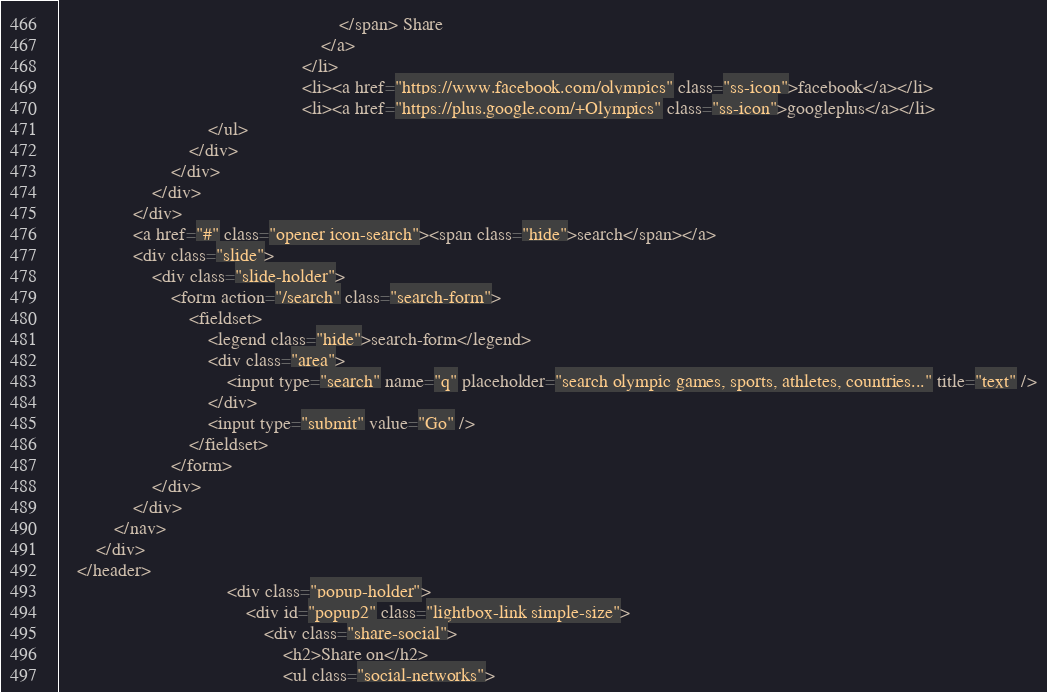<code> <loc_0><loc_0><loc_500><loc_500><_HTML_>                                                            </span> Share
                                                        </a>
                                                    </li>
                                                    <li><a href="https://www.facebook.com/olympics" class="ss-icon">facebook</a></li>
                                                    <li><a href="https://plus.google.com/+Olympics" class="ss-icon">googleplus</a></li>
                                </ul>
                            </div>
                        </div>
                    </div>
                </div>
                <a href="#" class="opener icon-search"><span class="hide">search</span></a>
                <div class="slide">
                    <div class="slide-holder">
                        <form action="/search" class="search-form">
                            <fieldset>
                                <legend class="hide">search-form</legend>
                                <div class="area">
                                    <input type="search" name="q" placeholder="search olympic games, sports, athletes, countries..." title="text" />
                                </div>
                                <input type="submit" value="Go" />
                            </fieldset>
                        </form>
                    </div>
                </div>
            </nav>
        </div>
    </header>
                                    <div class="popup-holder">
                                        <div id="popup2" class="lightbox-link simple-size">
                                            <div class="share-social">
                                                <h2>Share on</h2>
                                                <ul class="social-networks"></code> 